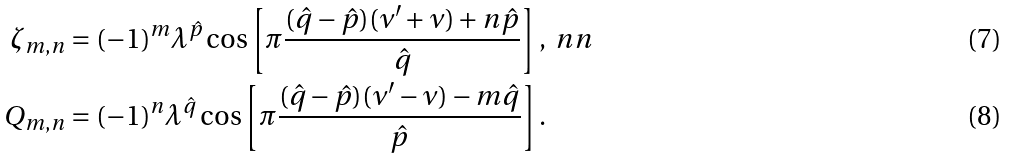<formula> <loc_0><loc_0><loc_500><loc_500>\zeta _ { m , n } & = ( - 1 ) ^ { m } \lambda ^ { \hat { p } } \cos \left [ \pi \frac { ( \hat { q } - \hat { p } ) ( \nu ^ { \prime } + \nu ) + n \hat { p } } { \hat { q } } \right ] , \ n n \\ Q _ { m , n } & = ( - 1 ) ^ { n } \lambda ^ { \hat { q } } \cos \left [ \pi \frac { ( \hat { q } - \hat { p } ) ( \nu ^ { \prime } - \nu ) - m \hat { q } } { \hat { p } } \right ] .</formula> 